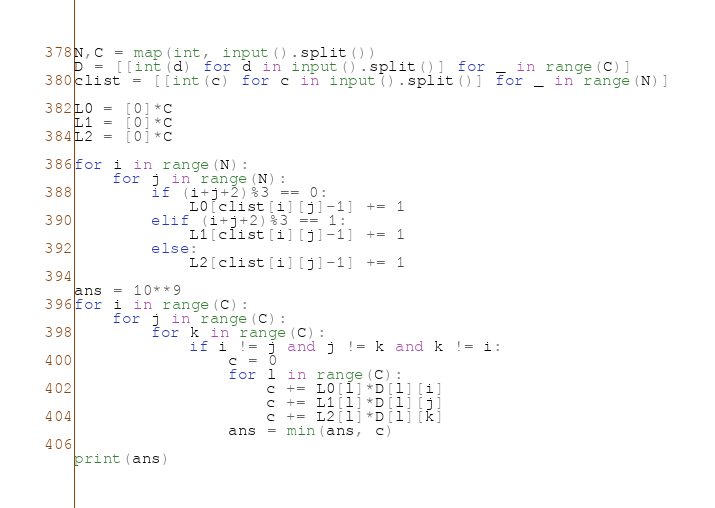Convert code to text. <code><loc_0><loc_0><loc_500><loc_500><_Python_>N,C = map(int, input().split())
D = [[int(d) for d in input().split()] for _ in range(C)]
clist = [[int(c) for c in input().split()] for _ in range(N)]

L0 = [0]*C
L1 = [0]*C
L2 = [0]*C

for i in range(N):
    for j in range(N):
        if (i+j+2)%3 == 0:
            L0[clist[i][j]-1] += 1
        elif (i+j+2)%3 == 1:
            L1[clist[i][j]-1] += 1
        else:
            L2[clist[i][j]-1] += 1
            
ans = 10**9
for i in range(C):
    for j in range(C):
        for k in range(C):
            if i != j and j != k and k != i:
                c = 0
                for l in range(C):
                    c += L0[l]*D[l][i]
                    c += L1[l]*D[l][j]
                    c += L2[l]*D[l][k]
                ans = min(ans, c)
                
print(ans)</code> 